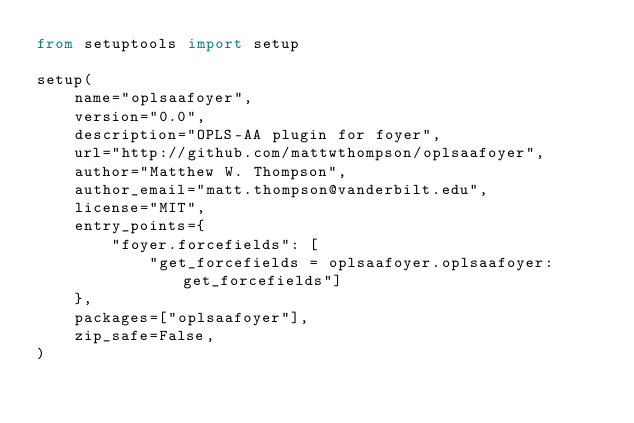<code> <loc_0><loc_0><loc_500><loc_500><_Python_>from setuptools import setup

setup(
    name="oplsaafoyer",
    version="0.0",
    description="OPLS-AA plugin for foyer",
    url="http://github.com/mattwthompson/oplsaafoyer",
    author="Matthew W. Thompson",
    author_email="matt.thompson@vanderbilt.edu",
    license="MIT",
    entry_points={
        "foyer.forcefields": [
            "get_forcefields = oplsaafoyer.oplsaafoyer:get_forcefields"]
    },
    packages=["oplsaafoyer"],
    zip_safe=False,
)
</code> 